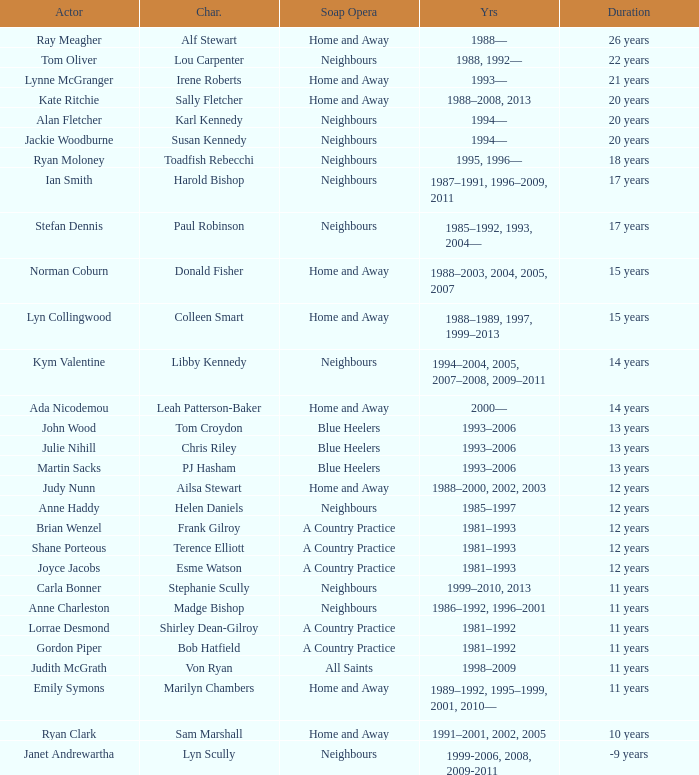Which actor played on Home and Away for 20 years? Kate Ritchie. 